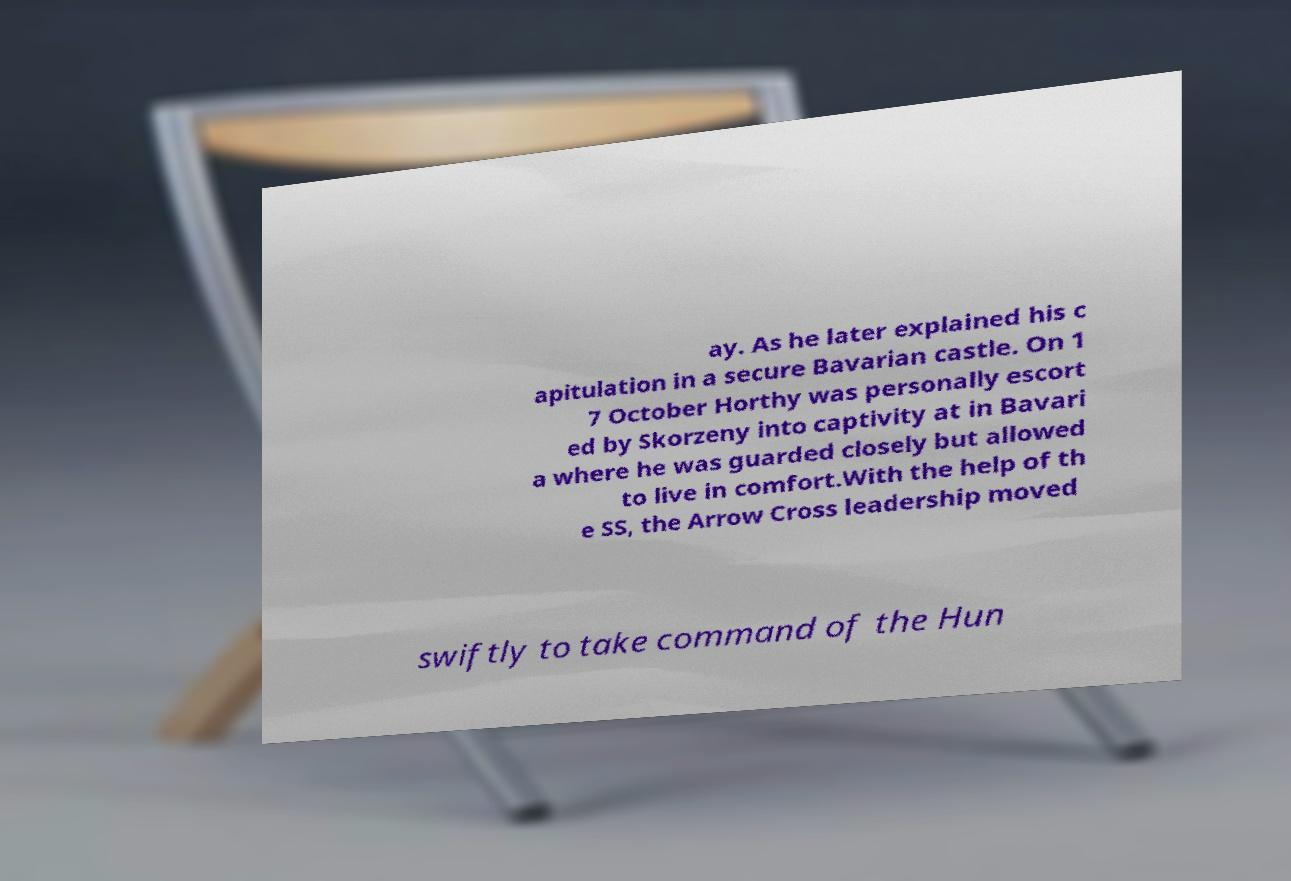Could you extract and type out the text from this image? ay. As he later explained his c apitulation in a secure Bavarian castle. On 1 7 October Horthy was personally escort ed by Skorzeny into captivity at in Bavari a where he was guarded closely but allowed to live in comfort.With the help of th e SS, the Arrow Cross leadership moved swiftly to take command of the Hun 